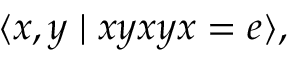<formula> <loc_0><loc_0><loc_500><loc_500>\langle x , y | x y x y x = e \rangle ,</formula> 